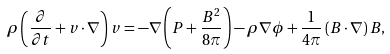<formula> <loc_0><loc_0><loc_500><loc_500>\rho \left ( \frac { \partial } { \partial t } + v \cdot \nabla \right ) v = - \nabla \left ( P + \frac { B ^ { 2 } } { 8 \pi } \right ) - \rho \nabla \phi + \frac { 1 } { 4 \pi } \left ( B \cdot \nabla \right ) B ,</formula> 